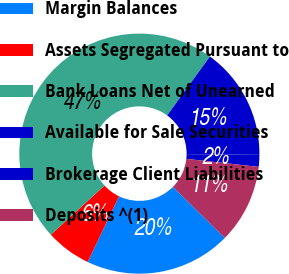<chart> <loc_0><loc_0><loc_500><loc_500><pie_chart><fcel>Margin Balances<fcel>Assets Segregated Pursuant to<fcel>Bank Loans Net of Unearned<fcel>Available for Sale Securities<fcel>Brokerage Client Liabilities<fcel>Deposits ^(1)<nl><fcel>19.68%<fcel>6.12%<fcel>46.8%<fcel>15.16%<fcel>1.6%<fcel>10.64%<nl></chart> 